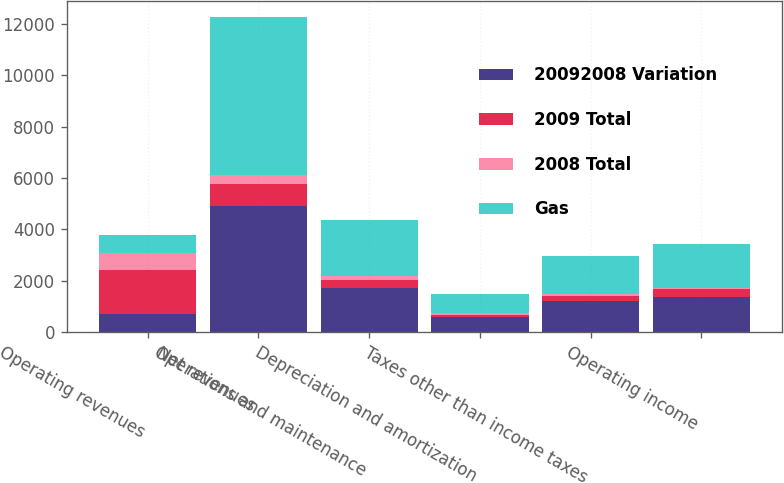Convert chart. <chart><loc_0><loc_0><loc_500><loc_500><stacked_bar_chart><ecel><fcel>Operating revenues<fcel>Net revenues<fcel>Operations and maintenance<fcel>Depreciation and amortization<fcel>Taxes other than income taxes<fcel>Operating income<nl><fcel>20092008 Variation<fcel>702.5<fcel>4898<fcel>1734<fcel>587<fcel>1209<fcel>1368<nl><fcel>2009 Total<fcel>1701<fcel>883<fcel>281<fcel>98<fcel>195<fcel>309<nl><fcel>2008 Total<fcel>661<fcel>351<fcel>171<fcel>59<fcel>82<fcel>39<nl><fcel>Gas<fcel>702.5<fcel>6132<fcel>2186<fcel>744<fcel>1486<fcel>1716<nl></chart> 